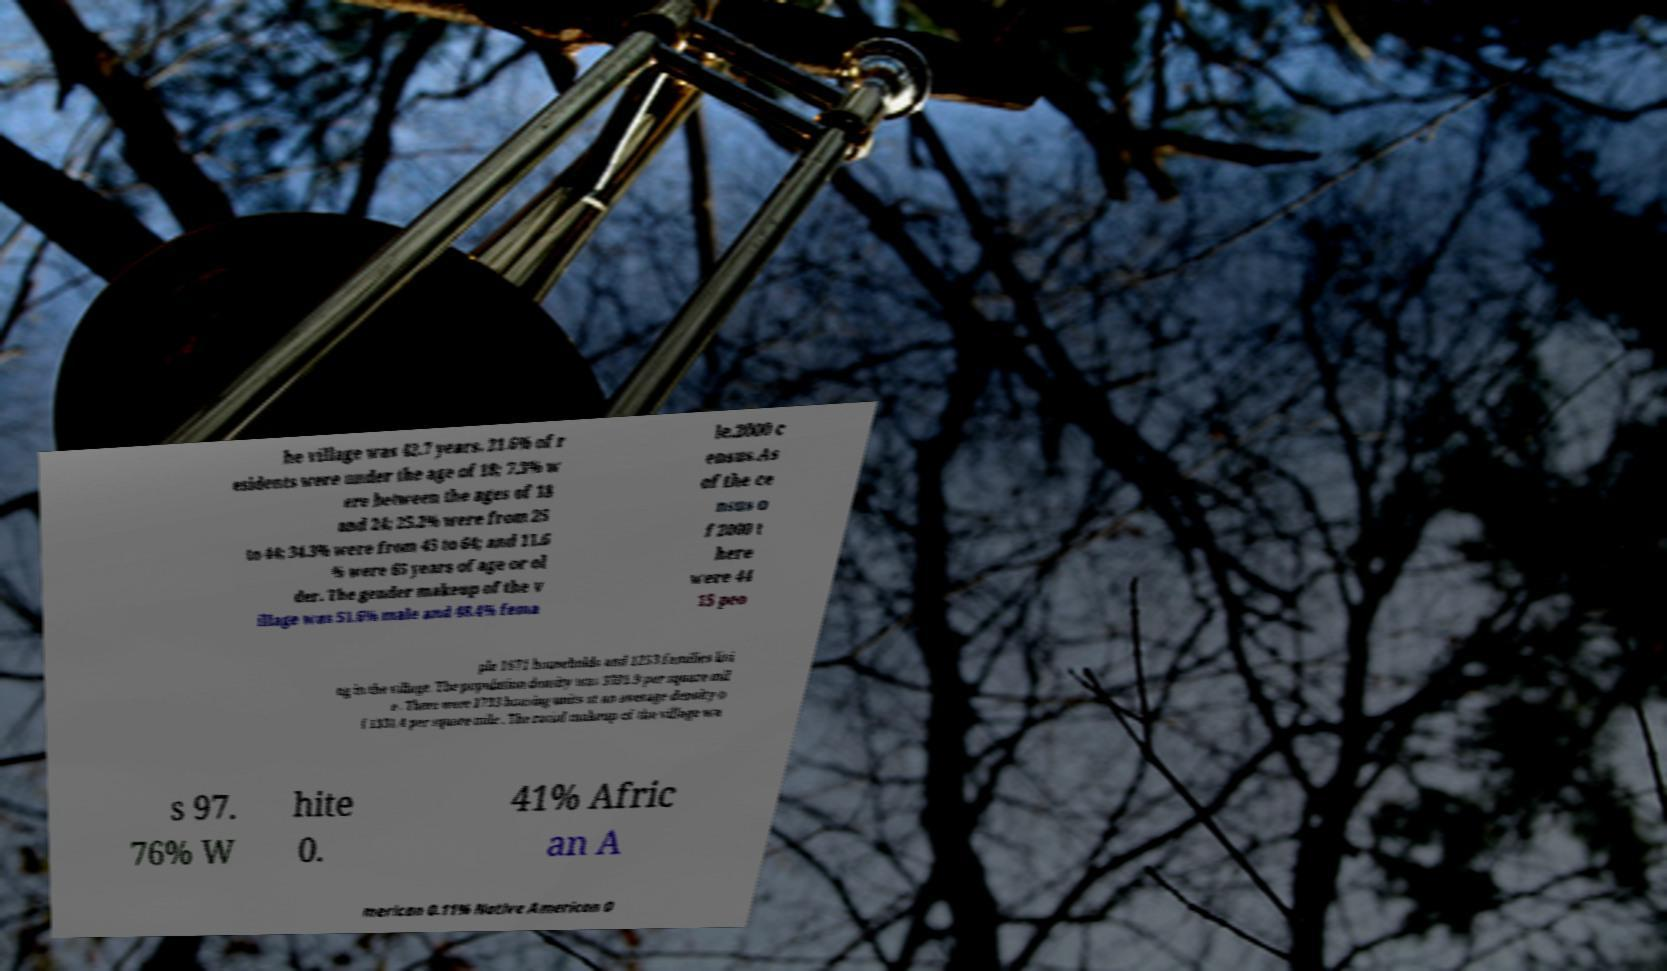Can you accurately transcribe the text from the provided image for me? he village was 42.7 years. 21.6% of r esidents were under the age of 18; 7.3% w ere between the ages of 18 and 24; 25.2% were from 25 to 44; 34.3% were from 45 to 64; and 11.6 % were 65 years of age or ol der. The gender makeup of the v illage was 51.6% male and 48.4% fema le.2000 c ensus.As of the ce nsus o f 2000 t here were 44 15 peo ple 1671 households and 1253 families livi ng in the village. The population density was 3391.9 per square mil e . There were 1733 housing units at an average density o f 1331.4 per square mile . The racial makeup of the village wa s 97. 76% W hite 0. 41% Afric an A merican 0.11% Native American 0 